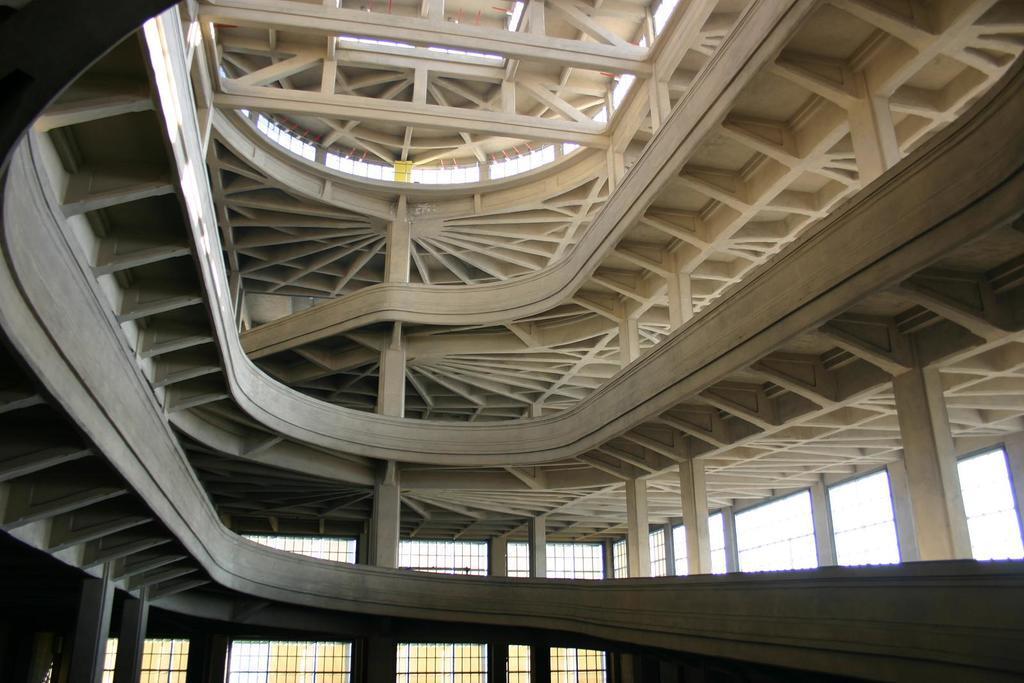In one or two sentences, can you explain what this image depicts? In this image we can see a building, windows and sky. 